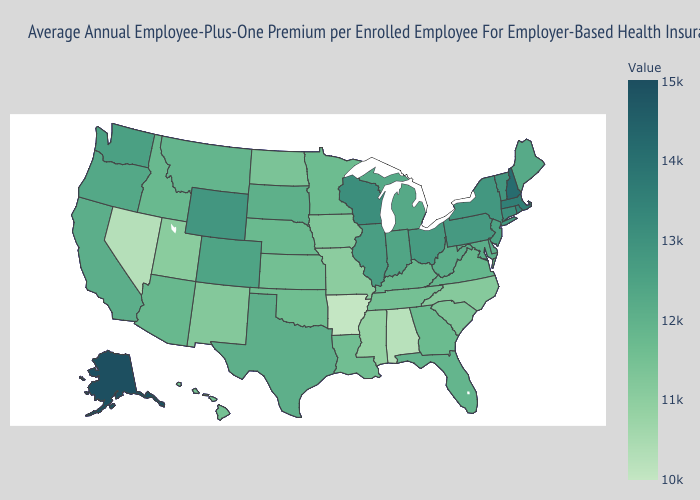Does Connecticut have a higher value than Massachusetts?
Be succinct. No. Does Colorado have a higher value than Arizona?
Give a very brief answer. Yes. Among the states that border New Jersey , does New York have the highest value?
Quick response, please. Yes. Which states have the highest value in the USA?
Quick response, please. Alaska. Does Alaska have the highest value in the West?
Short answer required. Yes. Which states have the lowest value in the South?
Quick response, please. Arkansas. 